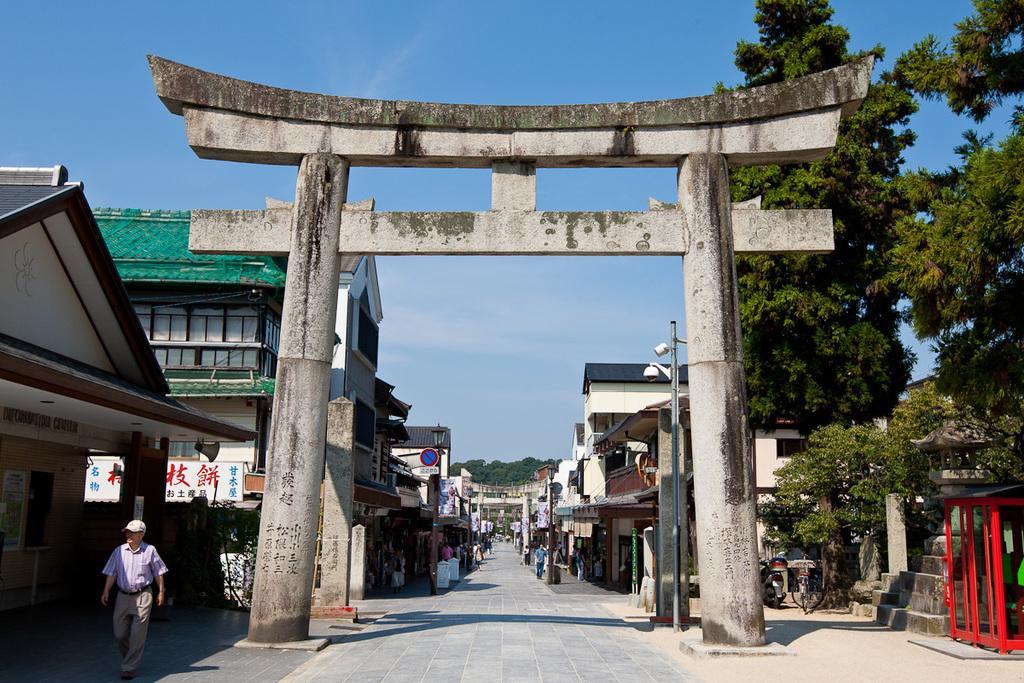Can you describe this image briefly? There is an entrance gate with pillars. On the sides there are buildings. On the right side there are trees, steps and a street light pole. On the left side there is a person with a cap is walking. Also there is a sign board and other boards. In the back there is sky. 